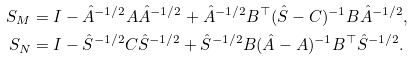Convert formula to latex. <formula><loc_0><loc_0><loc_500><loc_500>S _ { M } & = I - \hat { A } ^ { - 1 / 2 } A \hat { A } ^ { - 1 / 2 } + \hat { A } ^ { - 1 / 2 } B ^ { \top } ( \hat { S } - C ) ^ { - 1 } B \hat { A } ^ { - 1 / 2 } , \\ S _ { N } & = I - \hat { S } ^ { - 1 / 2 } C \hat { S } ^ { - 1 / 2 } + \hat { S } ^ { - 1 / 2 } B ( \hat { A } - A ) ^ { - 1 } B ^ { \top } \hat { S } ^ { - 1 / 2 } .</formula> 